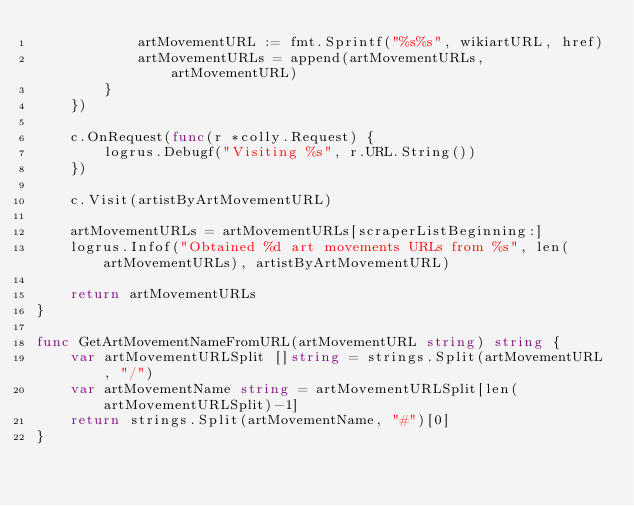Convert code to text. <code><loc_0><loc_0><loc_500><loc_500><_Go_>			artMovementURL := fmt.Sprintf("%s%s", wikiartURL, href)
			artMovementURLs = append(artMovementURLs, artMovementURL)
		}
	})

	c.OnRequest(func(r *colly.Request) {
		logrus.Debugf("Visiting %s", r.URL.String())
	})

	c.Visit(artistByArtMovementURL)

	artMovementURLs = artMovementURLs[scraperListBeginning:]
	logrus.Infof("Obtained %d art movements URLs from %s", len(artMovementURLs), artistByArtMovementURL)

	return artMovementURLs
}

func GetArtMovementNameFromURL(artMovementURL string) string {
	var artMovementURLSplit []string = strings.Split(artMovementURL, "/")
	var artMovementName string = artMovementURLSplit[len(artMovementURLSplit)-1]
	return strings.Split(artMovementName, "#")[0]
}
</code> 